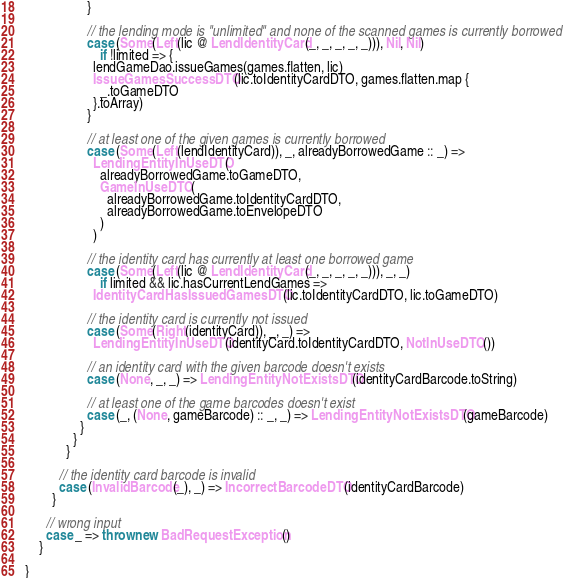<code> <loc_0><loc_0><loc_500><loc_500><_Scala_>                  }

                  // the lending mode is "unlimited" and none of the scanned games is currently borrowed
                  case (Some(Left(lic @ LendIdentityCard(_, _, _, _, _))), Nil, Nil)
                      if !limited => {
                    lendGameDao.issueGames(games.flatten, lic)
                    IssueGamesSuccessDTO(lic.toIdentityCardDTO, games.flatten.map {
                      _.toGameDTO
                    }.toArray)
                  }

                  // at least one of the given games is currently borrowed
                  case (Some(Left(lendIdentityCard)), _, alreadyBorrowedGame :: _) =>
                    LendingEntityInUseDTO(
                      alreadyBorrowedGame.toGameDTO,
                      GameInUseDTO(
                        alreadyBorrowedGame.toIdentityCardDTO,
                        alreadyBorrowedGame.toEnvelopeDTO
                      )
                    )

                  // the identity card has currently at least one borrowed game
                  case (Some(Left(lic @ LendIdentityCard(_, _, _, _, _))), _, _)
                      if limited && lic.hasCurrentLendGames =>
                    IdentityCardHasIssuedGamesDTO(lic.toIdentityCardDTO, lic.toGameDTO)

                  // the identity card is currently not issued
                  case (Some(Right(identityCard)), _, _) =>
                    LendingEntityInUseDTO(identityCard.toIdentityCardDTO, NotInUseDTO())

                  // an identity card with the given barcode doesn't exists
                  case (None, _, _) => LendingEntityNotExistsDTO(identityCardBarcode.toString)

                  // at least one of the game barcodes doesn't exist
                  case (_, (None, gameBarcode) :: _, _) => LendingEntityNotExistsDTO(gameBarcode)
                }
              }
            }

          // the identity card barcode is invalid
          case (InvalidBarcode(_), _) => IncorrectBarcodeDTO(identityCardBarcode)
        }

      // wrong input
      case _ => throw new BadRequestException()
    }

}
</code> 